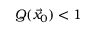<formula> <loc_0><loc_0><loc_500><loc_500>Q ( \vec { x } _ { 0 } ) < 1</formula> 